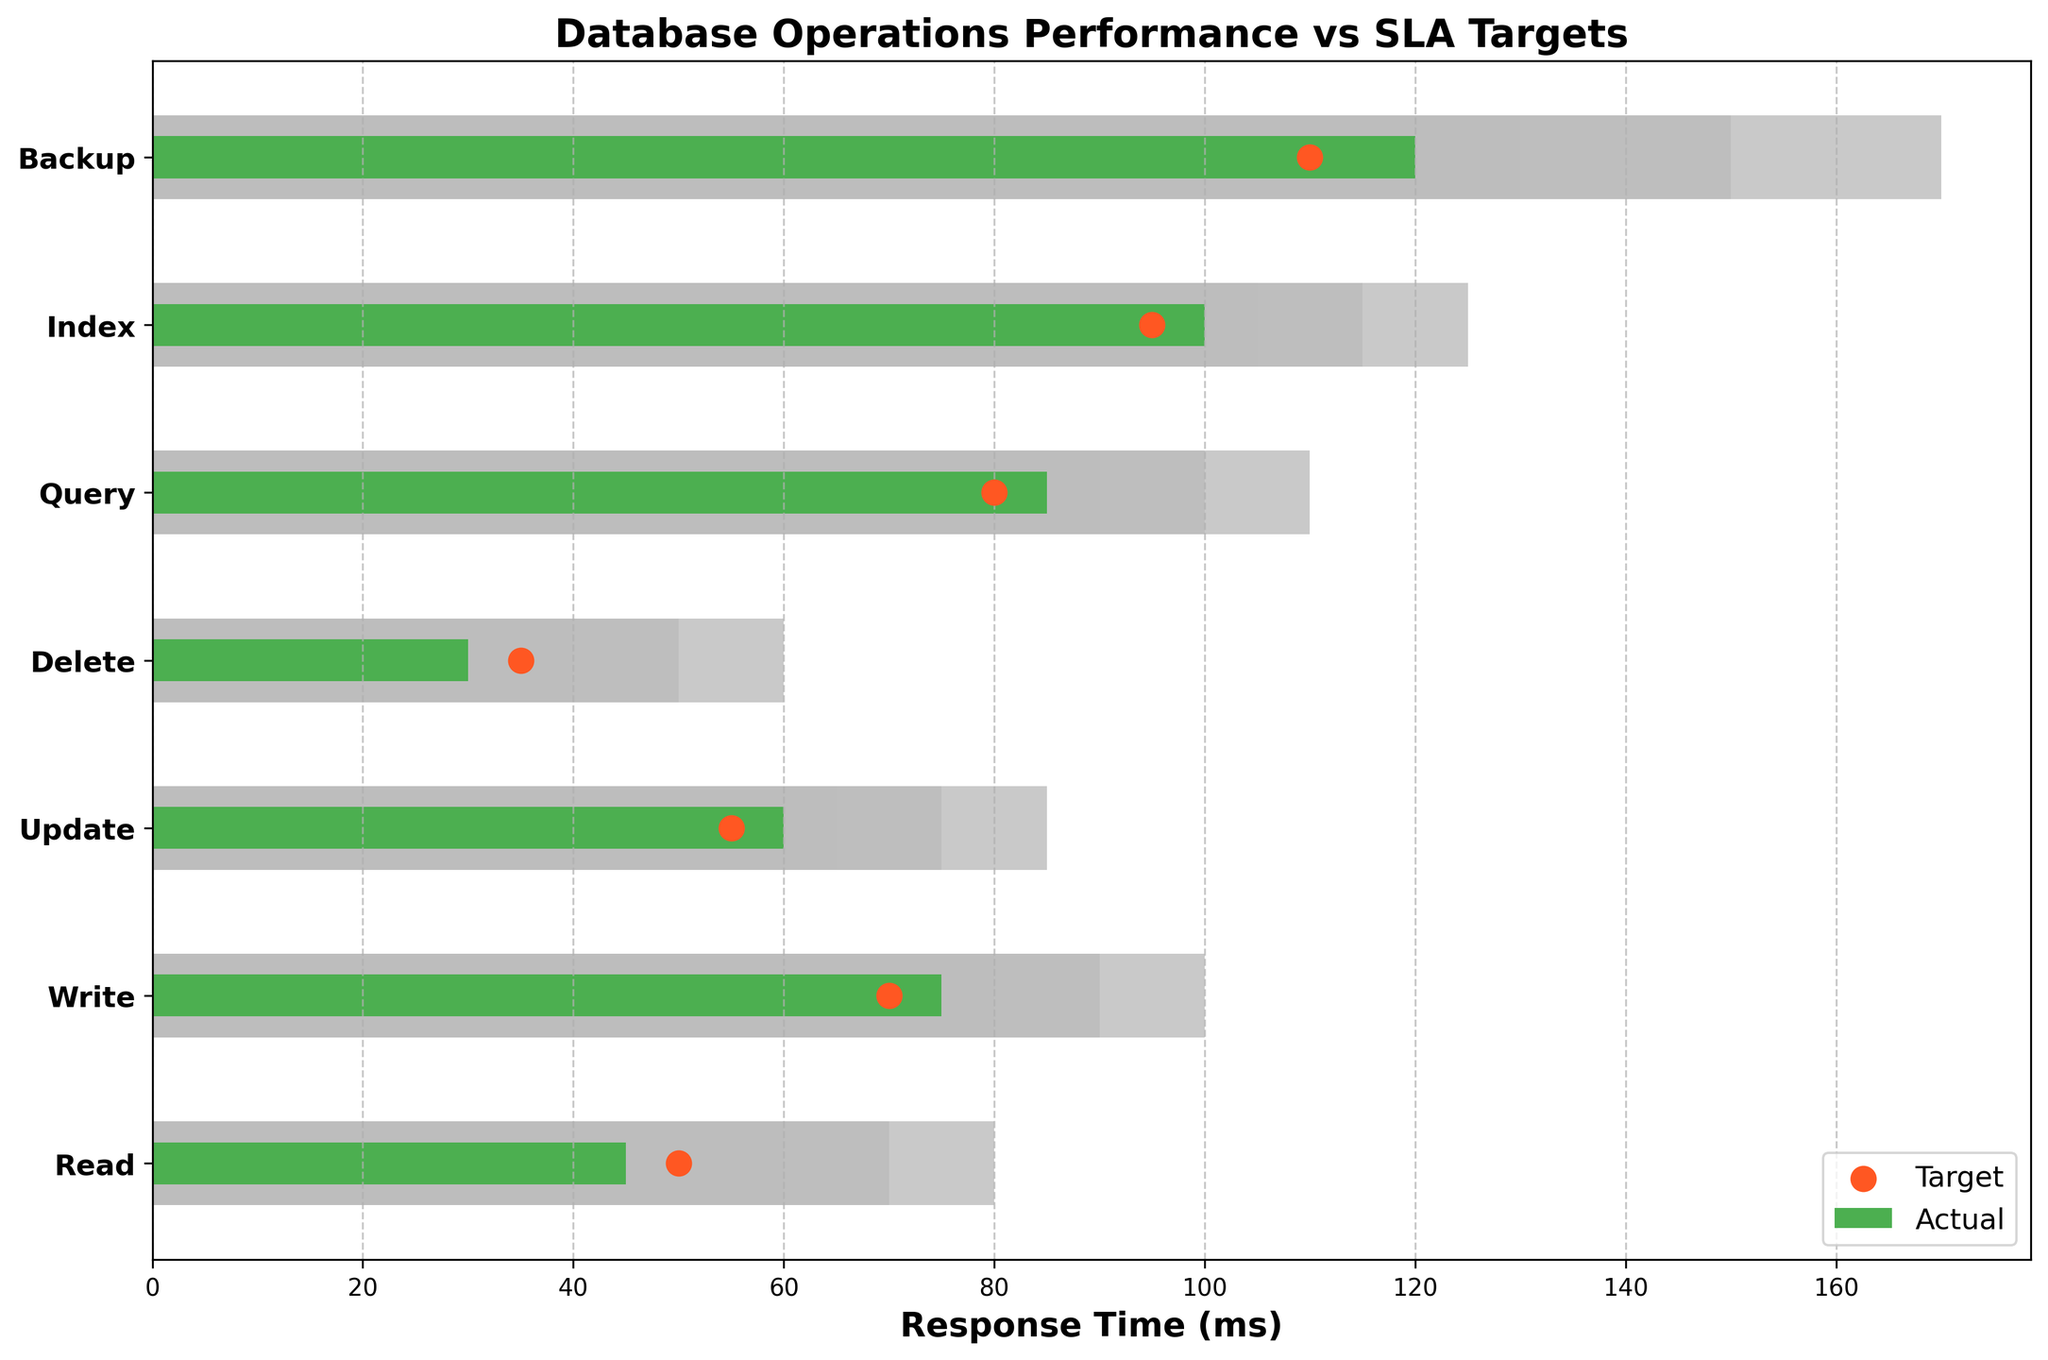What's the title of the figure? The title of the figure is usually positioned at the top center of the plot and indicates its main purpose. By checking the top of the figure, we can easily determine the title.
Answer: Database Operations Performance vs SLA Targets How many operations are displayed in the figure? The operations are listed as the y-tick labels, and each label corresponds to a horizontal bar on the plot. Counting these labels will provide the total number of operations.
Answer: 7 Which operation has the highest actual response time? By looking at the horizontal green bars representing actual response times, the one that extends the furthest horizontally represents the highest value.
Answer: Backup Does the 'Write' operation meet its target response time? For this, compare the actual performance (green bar) of the 'Write' operation to the target, represented by the red dot on the corresponding horizontal axis. The green bar should be less than or equal to the red dot.
Answer: No What is the target response time for the 'Index' operation? The target response time is represented by the red dot for the 'Index' operation. Checking its position along the horizontal axis will give the value.
Answer: 95 ms What is the difference between the actual and target response times for the 'Backup' operation? This involves finding the lengths of the green bar (actual value) and the position of the red dot (target value) for the 'Backup' operation, then subtracting the target from the actual.
Answer: 120 - 110 = 10 ms Which operation has the largest deviation from its target response time? Calculate the absolute differences between actual (green bars) and target (red dots) response times for all operations and identify the maximum value.
Answer: Backup Which operations are within their first threshold? Identify the operations where the actual response times (green bars) are within the first threshold, which is the area with the lightest shade of gray.
Answer: Read, Write, Update, Delete Compare the 'Query' and 'Index' operations in terms of actual response times. Which one performed better? Compare the lengths of the green bars for these two operations to see which one is shorter, indicating a better (lower) actual response time.
Answer: Query What range of response times is considered unacceptable for the 'Delete' operation? The unacceptable range is represented by the darkest shade of gray. Identify the value corresponding to the right edge of the darkest area on the 'Delete' operation bar.
Answer: Greater than 50 ms 